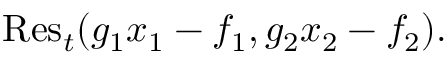<formula> <loc_0><loc_0><loc_500><loc_500>{ R e s } _ { t } ( g _ { 1 } x _ { 1 } - f _ { 1 } , g _ { 2 } x _ { 2 } - f _ { 2 } ) .</formula> 